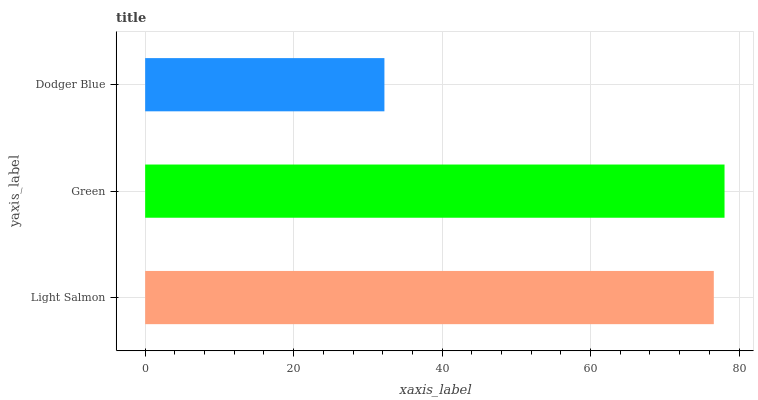Is Dodger Blue the minimum?
Answer yes or no. Yes. Is Green the maximum?
Answer yes or no. Yes. Is Green the minimum?
Answer yes or no. No. Is Dodger Blue the maximum?
Answer yes or no. No. Is Green greater than Dodger Blue?
Answer yes or no. Yes. Is Dodger Blue less than Green?
Answer yes or no. Yes. Is Dodger Blue greater than Green?
Answer yes or no. No. Is Green less than Dodger Blue?
Answer yes or no. No. Is Light Salmon the high median?
Answer yes or no. Yes. Is Light Salmon the low median?
Answer yes or no. Yes. Is Green the high median?
Answer yes or no. No. Is Dodger Blue the low median?
Answer yes or no. No. 